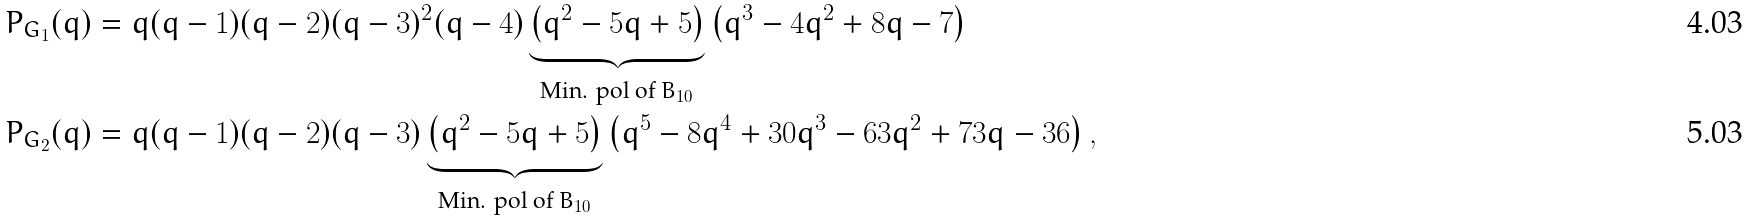<formula> <loc_0><loc_0><loc_500><loc_500>P _ { G _ { 1 } } ( q ) & = q ( q - 1 ) ( q - 2 ) ( q - 3 ) ^ { 2 } ( q - 4 ) \underbrace { \left ( q ^ { 2 } - 5 q + 5 \right ) } _ { \text {Min. pol of $B_{10}$} } \left ( q ^ { 3 } - 4 q ^ { 2 } + 8 q - 7 \right ) \\ P _ { G _ { 2 } } ( q ) & = q ( q - 1 ) ( q - 2 ) ( q - 3 ) \underbrace { \left ( q ^ { 2 } - 5 q + 5 \right ) } _ { \text {Min. pol of $B_{10}$} } \left ( q ^ { 5 } - 8 q ^ { 4 } + 3 0 q ^ { 3 } - 6 3 q ^ { 2 } + 7 3 q - 3 6 \right ) ,</formula> 